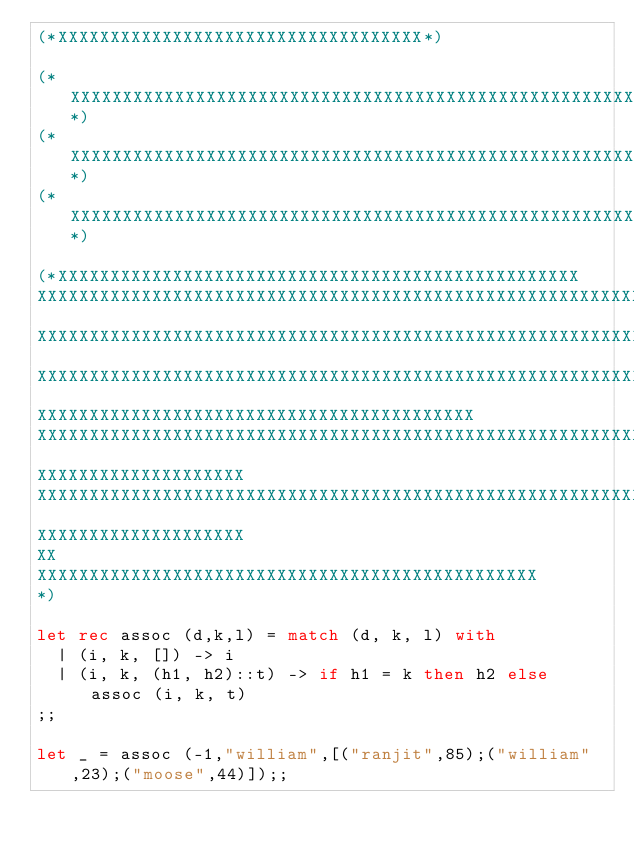Convert code to text. <code><loc_0><loc_0><loc_500><loc_500><_OCaml_>(*XXXXXXXXXXXXXXXXXXXXXXXXXXXXXXXXXXX*)

(*XXXXXXXXXXXXXXXXXXXXXXXXXXXXXXXXXXXXXXXXXXXXXXXXXXXXXXXXXXXXXXXXXXXXXXXXXXXXXXXXXXXXXX*)
(*XXXXXXXXXXXXXXXXXXXXXXXXXXXXXXXXXXXXXXXXXXXXXXXXXXXXXXXXXXXXXXXXXXXXXXXXXXXXXXXXXXXXXX*)
(*XXXXXXXXXXXXXXXXXXXXXXXXXXXXXXXXXXXXXXXXXXXXXXXXXXXXXXXXXXXXXXXXXXXXXXXXXXXXXXXXXXXXXX*)

(*XXXXXXXXXXXXXXXXXXXXXXXXXXXXXXXXXXXXXXXXXXXXXXXXXX
XXXXXXXXXXXXXXXXXXXXXXXXXXXXXXXXXXXXXXXXXXXXXXXXXXXXXXXXXXXX
XXXXXXXXXXXXXXXXXXXXXXXXXXXXXXXXXXXXXXXXXXXXXXXXXXXXXXXXXXXXXXXXXXXXXXXXXXXXXXXXXXX
XXXXXXXXXXXXXXXXXXXXXXXXXXXXXXXXXXXXXXXXXXXXXXXXXXXXXXXXXXXXXXXXXXXXXXXXXXXXXXXXXXXXX
XXXXXXXXXXXXXXXXXXXXXXXXXXXXXXXXXXXXXXXXXX
XXXXXXXXXXXXXXXXXXXXXXXXXXXXXXXXXXXXXXXXXXXXXXXXXXXXXXXXXXXXXXXXXXXXXXXXXX
XXXXXXXXXXXXXXXXXXXX
XXXXXXXXXXXXXXXXXXXXXXXXXXXXXXXXXXXXXXXXXXXXXXXXXXXXXXXXXXXXXXXXXXXXXX
XXXXXXXXXXXXXXXXXXXX
XX
XXXXXXXXXXXXXXXXXXXXXXXXXXXXXXXXXXXXXXXXXXXXXXXX
*)

let rec assoc (d,k,l) = match (d, k, l) with 
  | (i, k, []) -> i
  | (i, k, (h1, h2)::t) -> if h1 = k then h2 else assoc (i, k, t)
;;

let _ = assoc (-1,"william",[("ranjit",85);("william",23);("moose",44)]);;    
</code> 